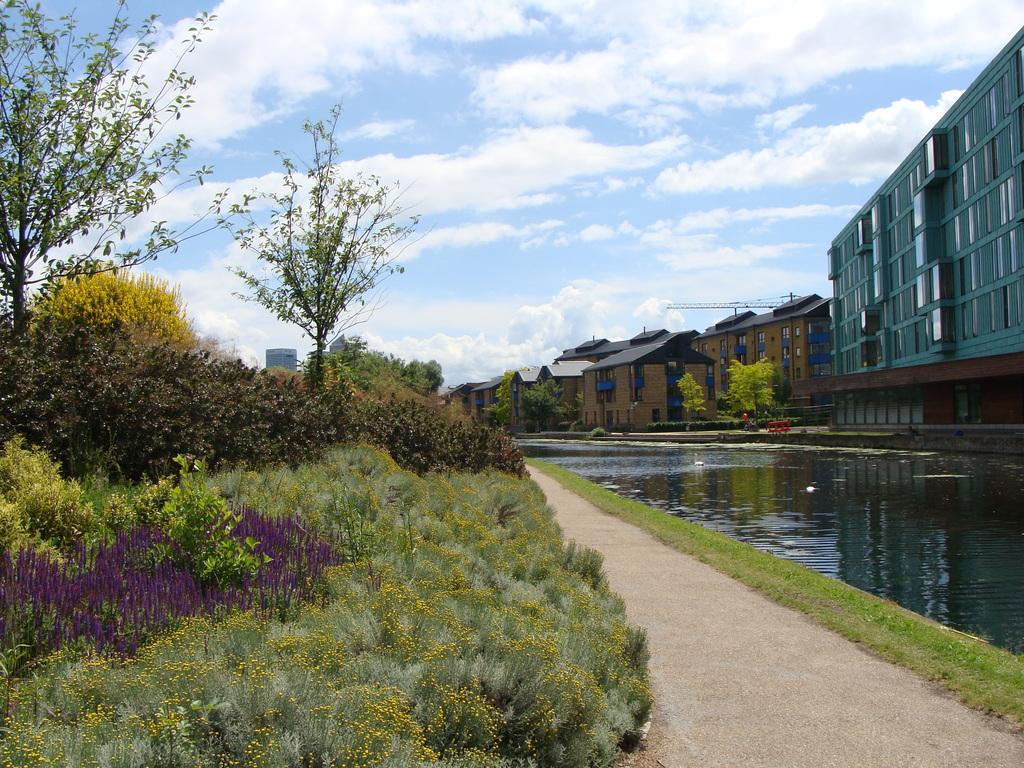What type of structures can be seen in the image? There are many buildings in the image. What natural elements are present in the image? There are trees, grass, and plants in the image. What type of construction equipment can be seen in the image? There is a crane in the image. What type of surface is visible in the image? There is a path in the image. What is visible in the background of the image? The sky is visible in the image. Is there any water visible in the image? Yes, there is water visible in the image. What size is the cannon in the image? There is no cannon present in the image. Who is the writer of the text on the buildings in the image? There is no text visible on the buildings in the image. 